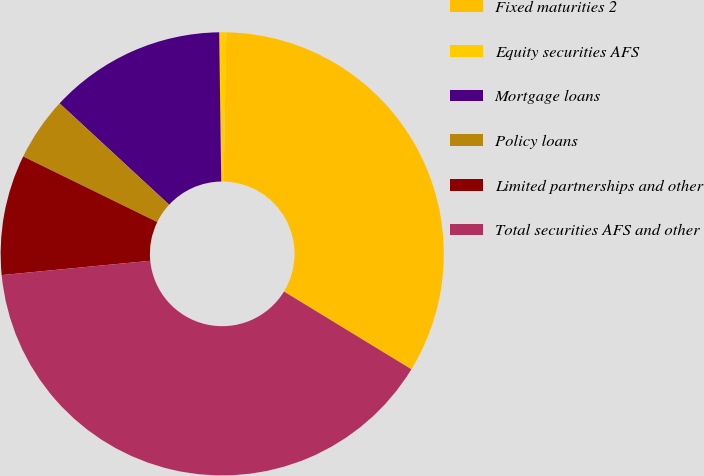<chart> <loc_0><loc_0><loc_500><loc_500><pie_chart><fcel>Fixed maturities 2<fcel>Equity securities AFS<fcel>Mortgage loans<fcel>Policy loans<fcel>Limited partnerships and other<fcel>Total securities AFS and other<nl><fcel>33.43%<fcel>0.51%<fcel>12.9%<fcel>4.64%<fcel>8.77%<fcel>39.75%<nl></chart> 